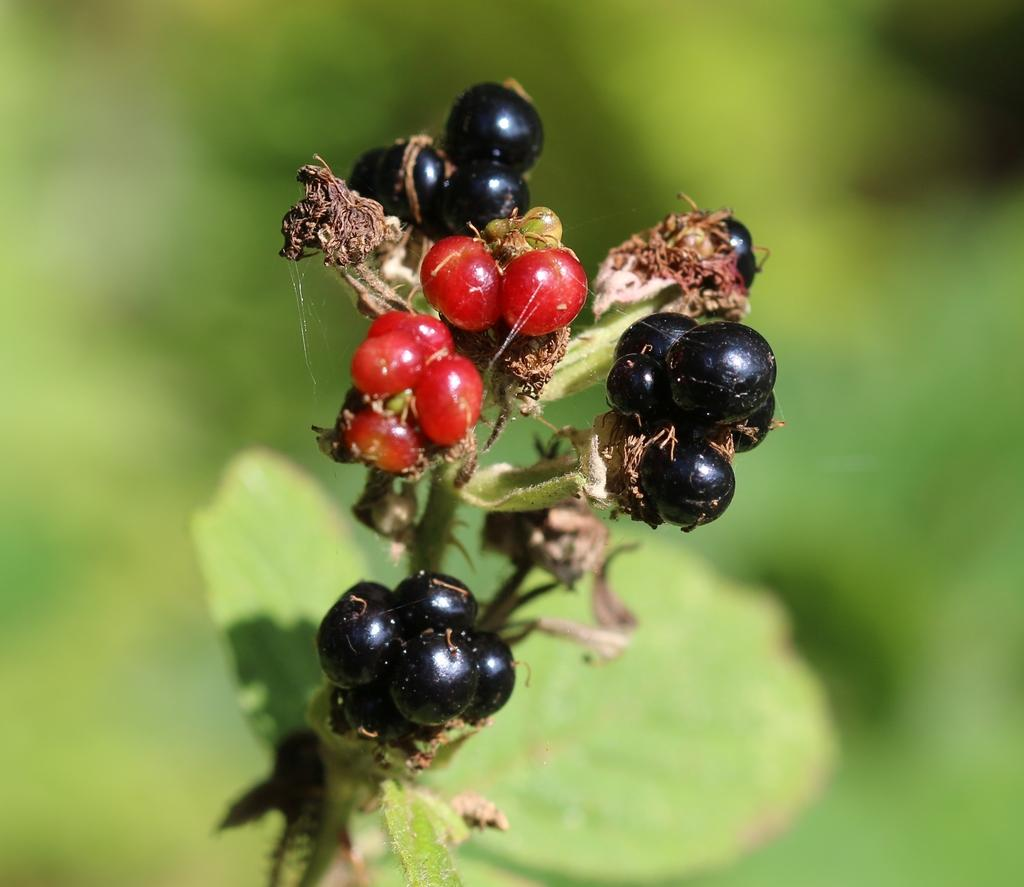What type of fruit can be seen in the image? There are berries in a plant in the image. What colors are the berries? The berries are black and red in color. Can you describe the background of the image? The background of the image is blurry. How many pigs are playing with the sisters in the image? There are no pigs or sisters present in the image; it features berries in a plant with a blurry background. 